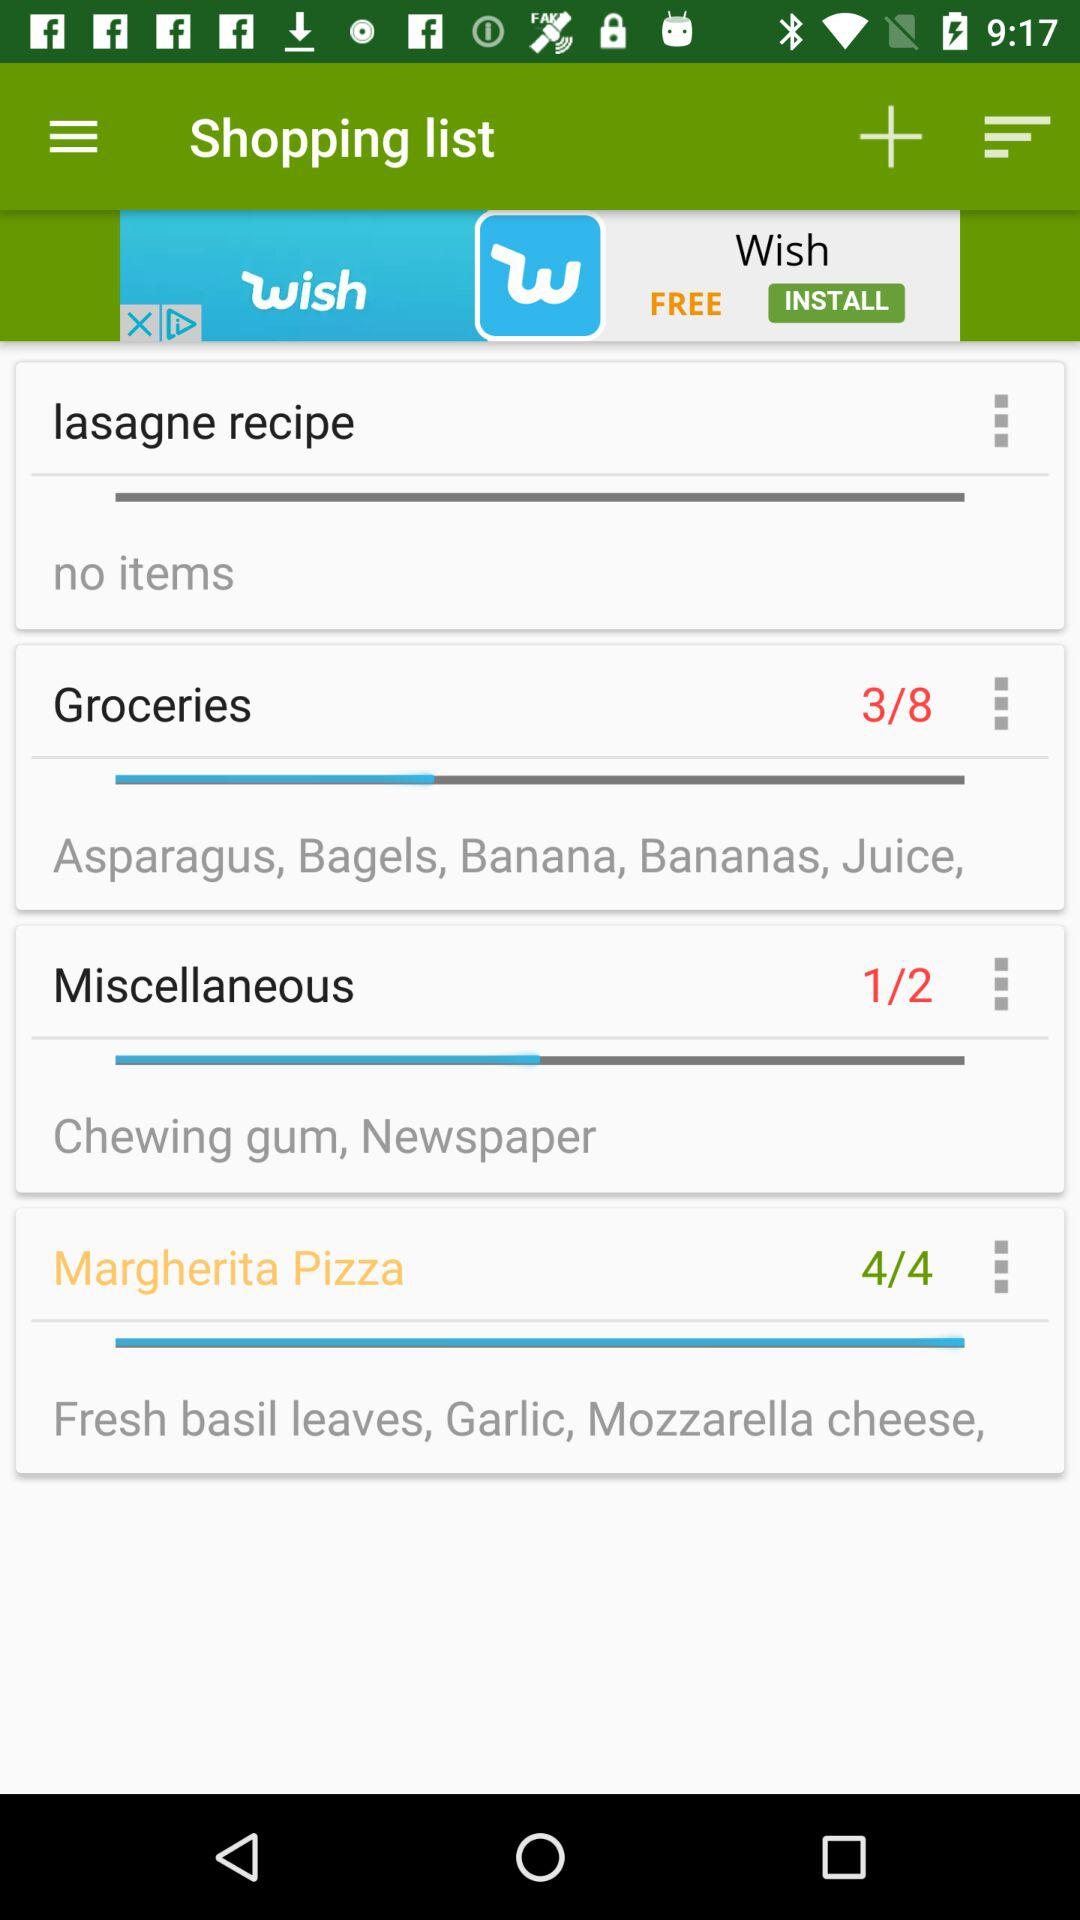What is the total count for miscellaneous? The total count for miscellaneous is 2. 